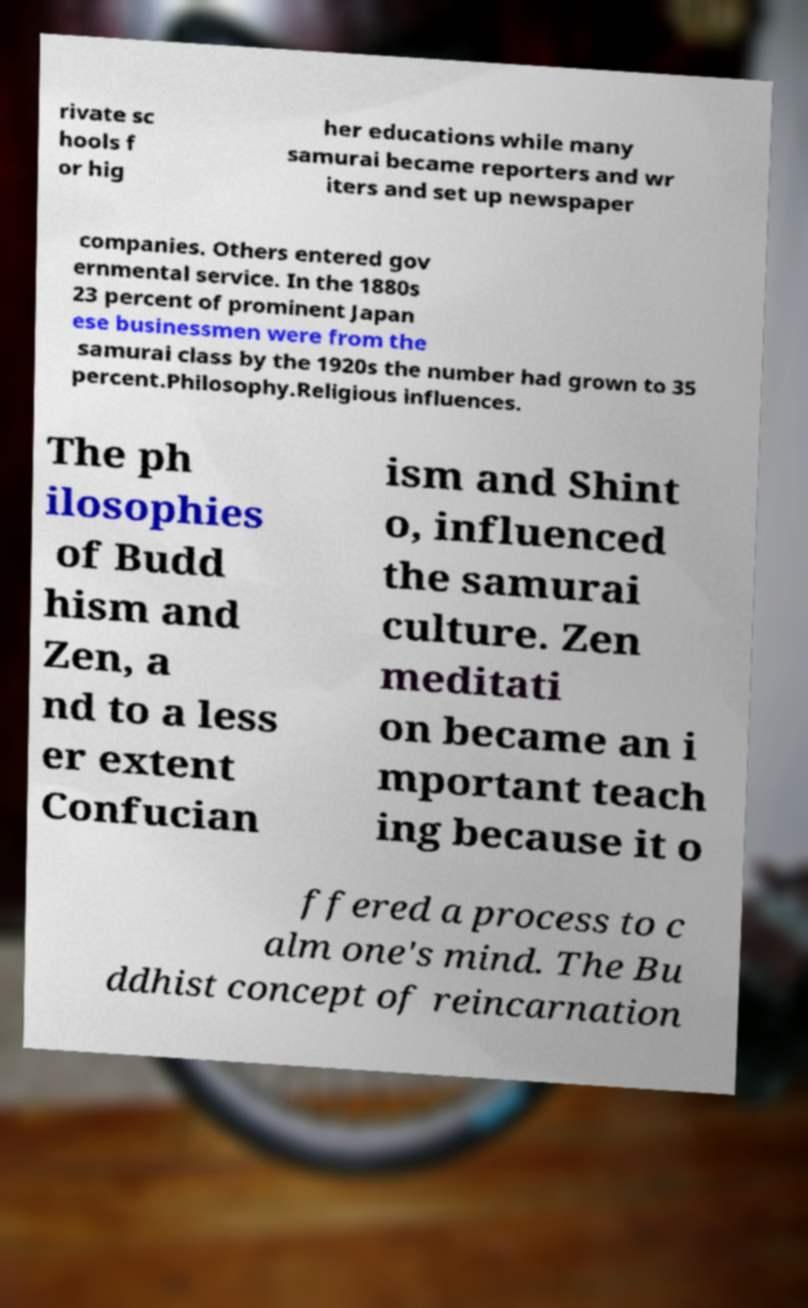Can you read and provide the text displayed in the image?This photo seems to have some interesting text. Can you extract and type it out for me? rivate sc hools f or hig her educations while many samurai became reporters and wr iters and set up newspaper companies. Others entered gov ernmental service. In the 1880s 23 percent of prominent Japan ese businessmen were from the samurai class by the 1920s the number had grown to 35 percent.Philosophy.Religious influences. The ph ilosophies of Budd hism and Zen, a nd to a less er extent Confucian ism and Shint o, influenced the samurai culture. Zen meditati on became an i mportant teach ing because it o ffered a process to c alm one's mind. The Bu ddhist concept of reincarnation 